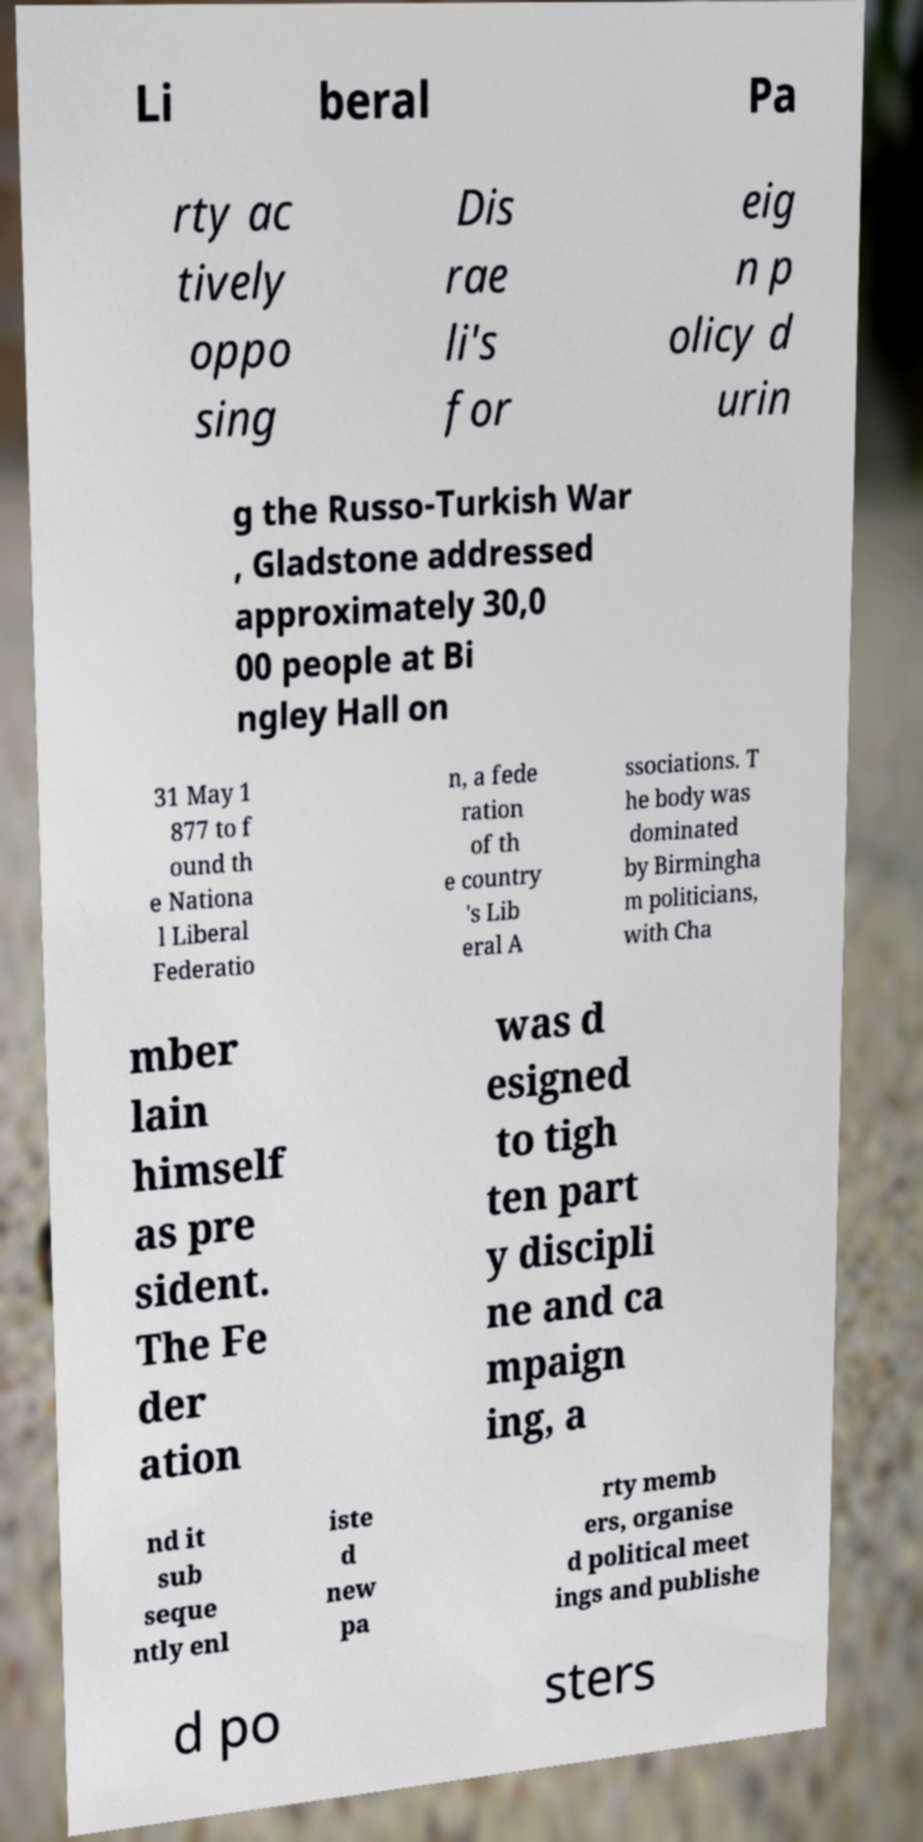I need the written content from this picture converted into text. Can you do that? Li beral Pa rty ac tively oppo sing Dis rae li's for eig n p olicy d urin g the Russo-Turkish War , Gladstone addressed approximately 30,0 00 people at Bi ngley Hall on 31 May 1 877 to f ound th e Nationa l Liberal Federatio n, a fede ration of th e country 's Lib eral A ssociations. T he body was dominated by Birmingha m politicians, with Cha mber lain himself as pre sident. The Fe der ation was d esigned to tigh ten part y discipli ne and ca mpaign ing, a nd it sub seque ntly enl iste d new pa rty memb ers, organise d political meet ings and publishe d po sters 